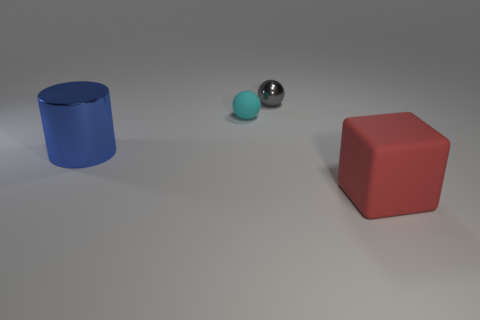Is the size of the ball that is on the right side of the cyan matte ball the same as the small cyan thing?
Offer a very short reply. Yes. How many things are right of the big cylinder and on the left side of the red block?
Provide a short and direct response. 2. There is a rubber object that is in front of the big object on the left side of the big red rubber object; what number of blue things are behind it?
Your answer should be very brief. 1. The blue object has what shape?
Your answer should be very brief. Cylinder. How many cyan balls are made of the same material as the large red object?
Make the answer very short. 1. There is a large thing that is the same material as the gray ball; what color is it?
Ensure brevity in your answer.  Blue. Does the cyan object have the same size as the object that is right of the gray ball?
Offer a very short reply. No. There is a tiny sphere to the left of the thing that is behind the matte object that is behind the red rubber object; what is its material?
Your answer should be very brief. Rubber. What number of objects are tiny matte things or small shiny things?
Give a very brief answer. 2. The gray metallic thing that is the same size as the cyan object is what shape?
Your answer should be very brief. Sphere. 